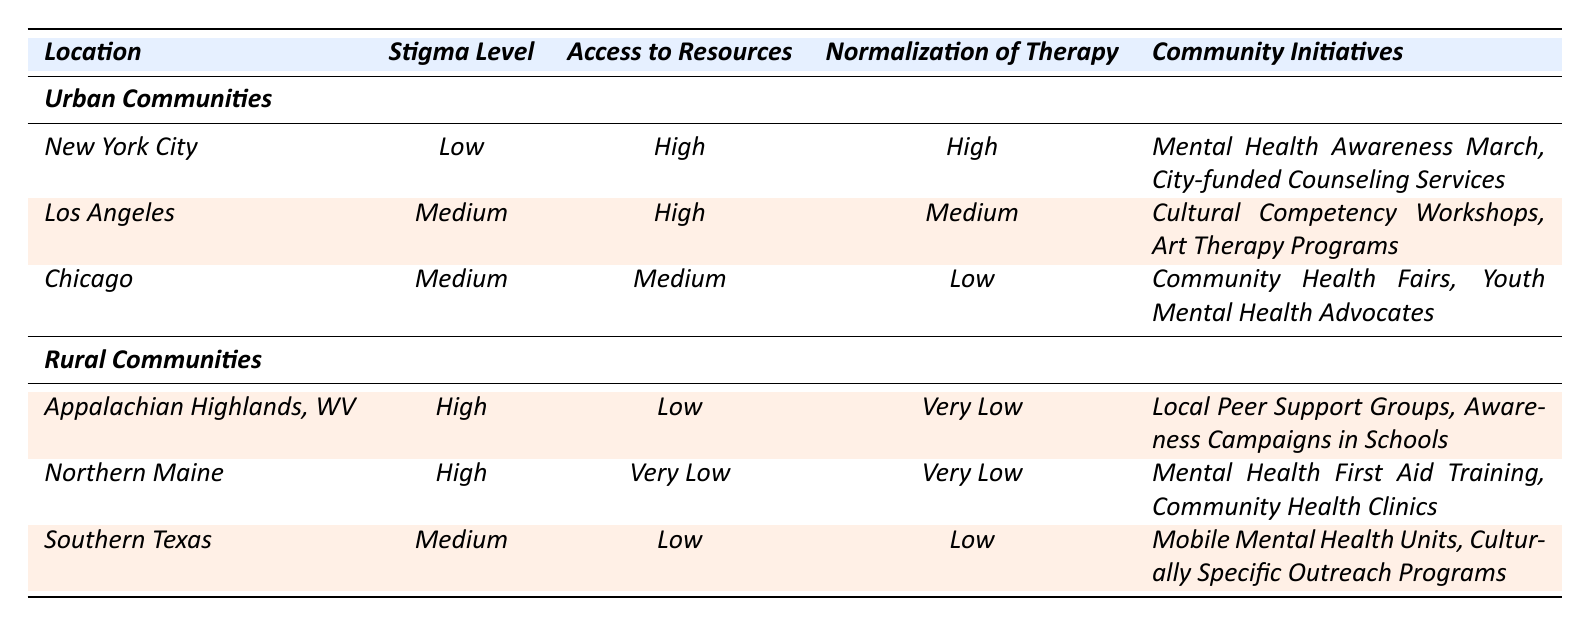What is the stigma level in New York City? The stigma level for New York City is directly listed in the table under the "Stigma Level" column.
Answer: Low Which community has the highest level of stigma? Among the listed communities, both Appalachian Highlands and Northern Maine have a stigma level categorized as High.
Answer: Appalachian Highlands and Northern Maine What initiatives are listed for Southern Texas? The community initiatives for Southern Texas are specified in the last column. They include "Mobile Mental Health Units" and "Culturally Specific Outreach Programs".
Answer: Mobile Mental Health Units, Culturally Specific Outreach Programs How does the access to resources in rural communities compare to urban communities on average? Urban communities generally have high and medium access to resources, while rural communities have low or very low access. Thus, the average access value is lower in rural areas.
Answer: Lower in rural communities Is there a community initiative for mental health awareness in Los Angeles? Yes, Los Angeles has initiatives aimed at cultural competency and art therapy, which support mental health awareness indirectly.
Answer: Yes What is the difference in the normalization of therapy between Chicago and Northern Maine? Chicago has a normalization of therapy level categorized as Low, while Northern Maine is categorized as Very Low. The difference is one level, with Northern Maine having a lower normalization.
Answer: One level Which urban community has the highest access to resources? New York City and Los Angeles both have a high access to resources, but only New York City has access categorized as High with all its listed initiatives probably funded by the city.
Answer: New York City What percentage of rural communities have a stigma level classified as High? Two out of three rural communities have a stigma level of High, so the percentage is (2/3) * 100 = 66.67%.
Answer: 66.67% Are community health fairs indicated as a community initiative for any urban community? No, community health fairs are listed only under the rural community Chicago, which doesn't indicate such initiative for other urban communities.
Answer: No What can be inferred about the normalization of therapy from urban to rural communities? A comparison shows that urban communities generally have a higher normalization of therapy (Low to High) compared to rural communities (Very Low to Medium), indicating an overall cultural acceptance in urban areas.
Answer: Higher normalization in urban communities 